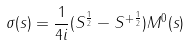Convert formula to latex. <formula><loc_0><loc_0><loc_500><loc_500>\sigma ( s ) = \frac { 1 } { 4 i } ( S ^ { \frac { 1 } { 2 } } - S ^ { + \frac { 1 } { 2 } } ) M ^ { 0 } ( s )</formula> 